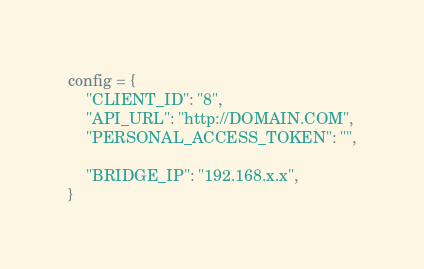<code> <loc_0><loc_0><loc_500><loc_500><_Python_>config = {
    "CLIENT_ID": "8",
    "API_URL": "http://DOMAIN.COM",
    "PERSONAL_ACCESS_TOKEN": "",

    "BRIDGE_IP": "192.168.x.x",
}
</code> 